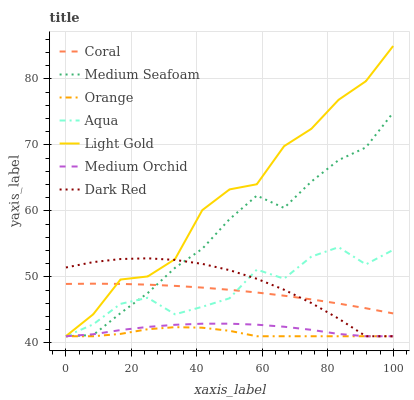Does Orange have the minimum area under the curve?
Answer yes or no. Yes. Does Light Gold have the maximum area under the curve?
Answer yes or no. Yes. Does Coral have the minimum area under the curve?
Answer yes or no. No. Does Coral have the maximum area under the curve?
Answer yes or no. No. Is Coral the smoothest?
Answer yes or no. Yes. Is Aqua the roughest?
Answer yes or no. Yes. Is Medium Orchid the smoothest?
Answer yes or no. No. Is Medium Orchid the roughest?
Answer yes or no. No. Does Dark Red have the lowest value?
Answer yes or no. Yes. Does Coral have the lowest value?
Answer yes or no. No. Does Light Gold have the highest value?
Answer yes or no. Yes. Does Coral have the highest value?
Answer yes or no. No. Is Aqua less than Light Gold?
Answer yes or no. Yes. Is Light Gold greater than Orange?
Answer yes or no. Yes. Does Orange intersect Dark Red?
Answer yes or no. Yes. Is Orange less than Dark Red?
Answer yes or no. No. Is Orange greater than Dark Red?
Answer yes or no. No. Does Aqua intersect Light Gold?
Answer yes or no. No. 